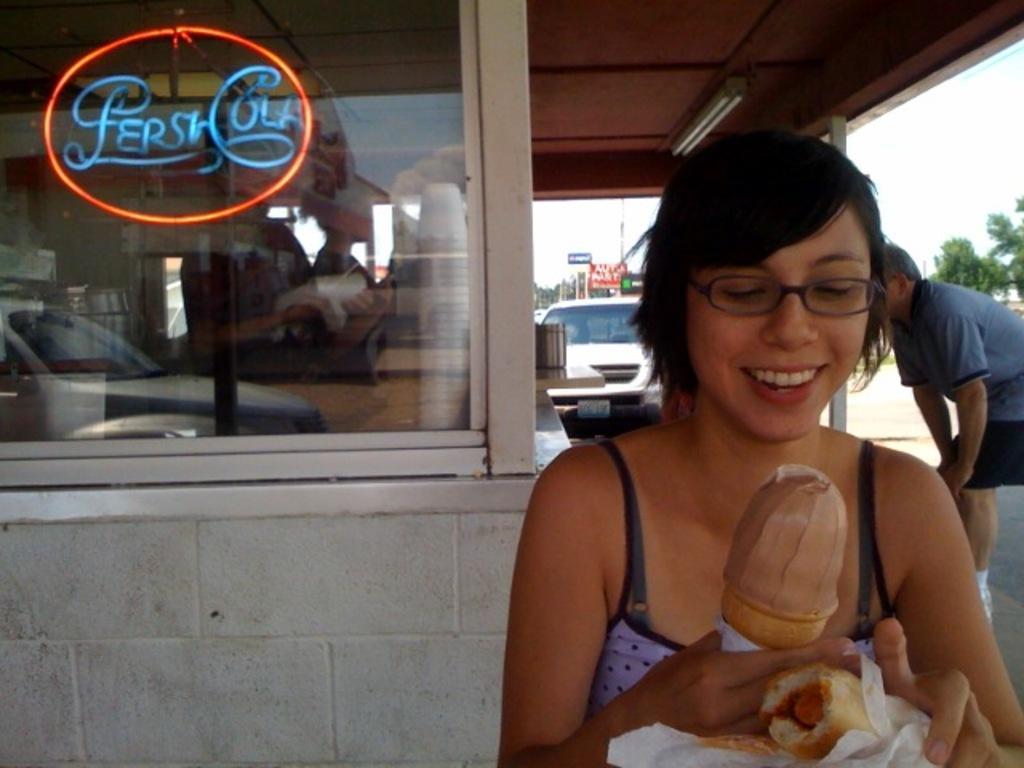In one or two sentences, can you explain what this image depicts? In this image I can see a person holding food items. Back to her there is another person. And there is a transparent glass, on which I can see reflection of a car and some other objects. Also there are trees, boards, there is a vehicle and there is sky. 